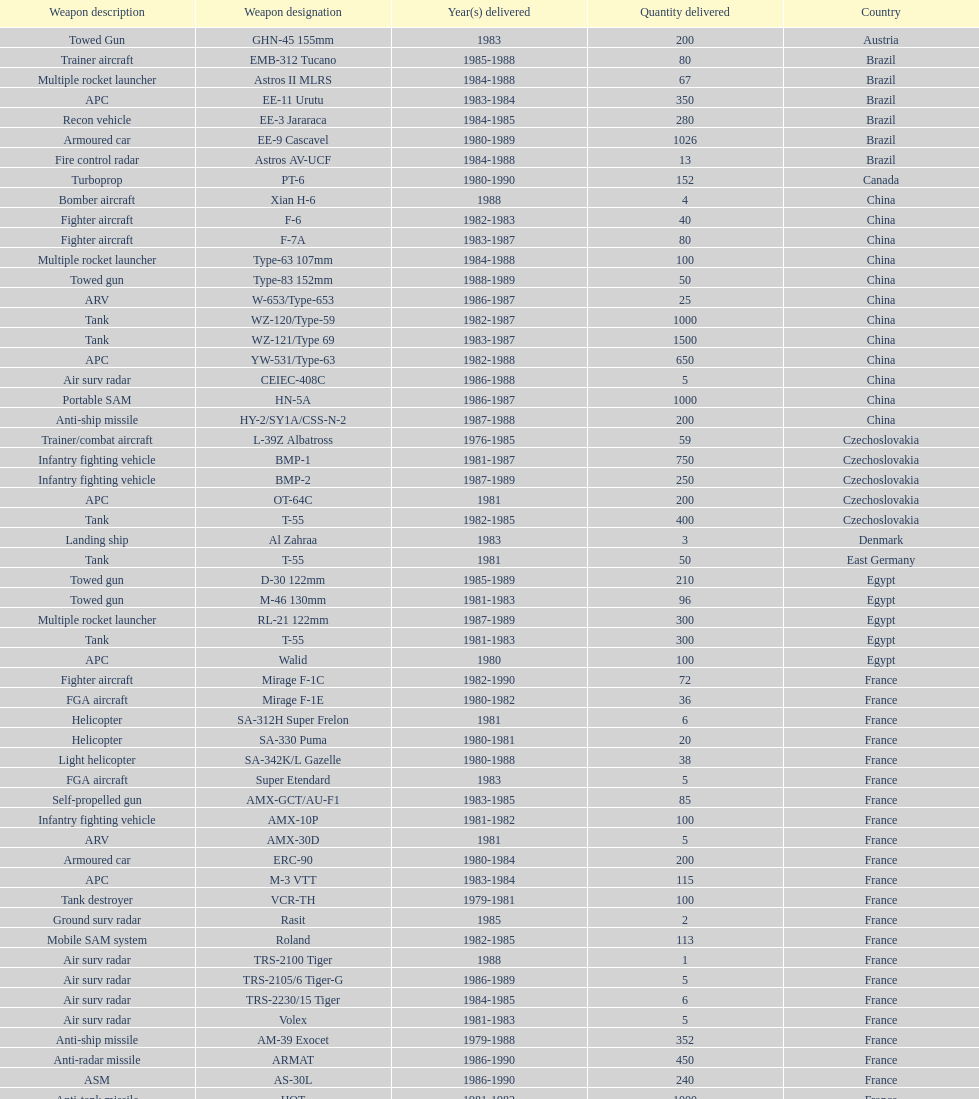Write the full table. {'header': ['Weapon description', 'Weapon designation', 'Year(s) delivered', 'Quantity delivered', 'Country'], 'rows': [['Towed Gun', 'GHN-45 155mm', '1983', '200', 'Austria'], ['Trainer aircraft', 'EMB-312 Tucano', '1985-1988', '80', 'Brazil'], ['Multiple rocket launcher', 'Astros II MLRS', '1984-1988', '67', 'Brazil'], ['APC', 'EE-11 Urutu', '1983-1984', '350', 'Brazil'], ['Recon vehicle', 'EE-3 Jararaca', '1984-1985', '280', 'Brazil'], ['Armoured car', 'EE-9 Cascavel', '1980-1989', '1026', 'Brazil'], ['Fire control radar', 'Astros AV-UCF', '1984-1988', '13', 'Brazil'], ['Turboprop', 'PT-6', '1980-1990', '152', 'Canada'], ['Bomber aircraft', 'Xian H-6', '1988', '4', 'China'], ['Fighter aircraft', 'F-6', '1982-1983', '40', 'China'], ['Fighter aircraft', 'F-7A', '1983-1987', '80', 'China'], ['Multiple rocket launcher', 'Type-63 107mm', '1984-1988', '100', 'China'], ['Towed gun', 'Type-83 152mm', '1988-1989', '50', 'China'], ['ARV', 'W-653/Type-653', '1986-1987', '25', 'China'], ['Tank', 'WZ-120/Type-59', '1982-1987', '1000', 'China'], ['Tank', 'WZ-121/Type 69', '1983-1987', '1500', 'China'], ['APC', 'YW-531/Type-63', '1982-1988', '650', 'China'], ['Air surv radar', 'CEIEC-408C', '1986-1988', '5', 'China'], ['Portable SAM', 'HN-5A', '1986-1987', '1000', 'China'], ['Anti-ship missile', 'HY-2/SY1A/CSS-N-2', '1987-1988', '200', 'China'], ['Trainer/combat aircraft', 'L-39Z Albatross', '1976-1985', '59', 'Czechoslovakia'], ['Infantry fighting vehicle', 'BMP-1', '1981-1987', '750', 'Czechoslovakia'], ['Infantry fighting vehicle', 'BMP-2', '1987-1989', '250', 'Czechoslovakia'], ['APC', 'OT-64C', '1981', '200', 'Czechoslovakia'], ['Tank', 'T-55', '1982-1985', '400', 'Czechoslovakia'], ['Landing ship', 'Al Zahraa', '1983', '3', 'Denmark'], ['Tank', 'T-55', '1981', '50', 'East Germany'], ['Towed gun', 'D-30 122mm', '1985-1989', '210', 'Egypt'], ['Towed gun', 'M-46 130mm', '1981-1983', '96', 'Egypt'], ['Multiple rocket launcher', 'RL-21 122mm', '1987-1989', '300', 'Egypt'], ['Tank', 'T-55', '1981-1983', '300', 'Egypt'], ['APC', 'Walid', '1980', '100', 'Egypt'], ['Fighter aircraft', 'Mirage F-1C', '1982-1990', '72', 'France'], ['FGA aircraft', 'Mirage F-1E', '1980-1982', '36', 'France'], ['Helicopter', 'SA-312H Super Frelon', '1981', '6', 'France'], ['Helicopter', 'SA-330 Puma', '1980-1981', '20', 'France'], ['Light helicopter', 'SA-342K/L Gazelle', '1980-1988', '38', 'France'], ['FGA aircraft', 'Super Etendard', '1983', '5', 'France'], ['Self-propelled gun', 'AMX-GCT/AU-F1', '1983-1985', '85', 'France'], ['Infantry fighting vehicle', 'AMX-10P', '1981-1982', '100', 'France'], ['ARV', 'AMX-30D', '1981', '5', 'France'], ['Armoured car', 'ERC-90', '1980-1984', '200', 'France'], ['APC', 'M-3 VTT', '1983-1984', '115', 'France'], ['Tank destroyer', 'VCR-TH', '1979-1981', '100', 'France'], ['Ground surv radar', 'Rasit', '1985', '2', 'France'], ['Mobile SAM system', 'Roland', '1982-1985', '113', 'France'], ['Air surv radar', 'TRS-2100 Tiger', '1988', '1', 'France'], ['Air surv radar', 'TRS-2105/6 Tiger-G', '1986-1989', '5', 'France'], ['Air surv radar', 'TRS-2230/15 Tiger', '1984-1985', '6', 'France'], ['Air surv radar', 'Volex', '1981-1983', '5', 'France'], ['Anti-ship missile', 'AM-39 Exocet', '1979-1988', '352', 'France'], ['Anti-radar missile', 'ARMAT', '1986-1990', '450', 'France'], ['ASM', 'AS-30L', '1986-1990', '240', 'France'], ['Anti-tank missile', 'HOT', '1981-1982', '1000', 'France'], ['SRAAM', 'R-550 Magic-1', '1981-1985', '534', 'France'], ['SAM', 'Roland-2', '1981-1990', '2260', 'France'], ['BVRAAM', 'Super 530F', '1981-1985', '300', 'France'], ['Helicopter', 'BK-117', '1984-1989', '22', 'West Germany'], ['Light Helicopter', 'Bo-105C', '1979-1982', '20', 'West Germany'], ['Light Helicopter', 'Bo-105L', '1988', '6', 'West Germany'], ['APC', 'PSZH-D-994', '1981', '300', 'Hungary'], ['Light Helicopter', 'A-109 Hirundo', '1982', '2', 'Italy'], ['Helicopter', 'S-61', '1982', '6', 'Italy'], ['Support ship', 'Stromboli class', '1981', '1', 'Italy'], ['Helicopter', 'S-76 Spirit', '1985', '2', 'Jordan'], ['Helicopter', 'Mi-2/Hoplite', '1984-1985', '15', 'Poland'], ['APC', 'MT-LB', '1983-1990', '750', 'Poland'], ['Tank', 'T-55', '1981-1982', '400', 'Poland'], ['Tank', 'T-72M1', '1982-1990', '500', 'Poland'], ['Tank', 'T-55', '1982-1984', '150', 'Romania'], ['Multiple rocket launcher', 'M-87 Orkan 262mm', '1988', '2', 'Yugoslavia'], ['Towed gun', 'G-5 155mm', '1985-1988', '200', 'South Africa'], ['Trainer aircraft', 'PC-7 Turbo trainer', '1980-1983', '52', 'Switzerland'], ['Trainer aircraft', 'PC-9', '1987-1990', '20', 'Switzerland'], ['APC/IFV', 'Roland', '1981', '100', 'Switzerland'], ['ARV', 'Chieftain/ARV', '1982', '29', 'United Kingdom'], ['Arty locating radar', 'Cymbeline', '1986-1988', '10', 'United Kingdom'], ['Light Helicopter', 'MD-500MD Defender', '1983', '30', 'United States'], ['Light Helicopter', 'Hughes-300/TH-55', '1983', '30', 'United States'], ['Light Helicopter', 'MD-530F', '1986', '26', 'United States'], ['Helicopter', 'Bell 214ST', '1988', '31', 'United States'], ['Strategic airlifter', 'Il-76M/Candid-B', '1978-1984', '33', 'Soviet Union'], ['Attack helicopter', 'Mi-24D/Mi-25/Hind-D', '1978-1984', '12', 'Soviet Union'], ['Transport helicopter', 'Mi-8/Mi-17/Hip-H', '1986-1987', '37', 'Soviet Union'], ['Transport helicopter', 'Mi-8TV/Hip-F', '1984', '30', 'Soviet Union'], ['Fighter aircraft', 'Mig-21bis/Fishbed-N', '1983-1984', '61', 'Soviet Union'], ['FGA aircraft', 'Mig-23BN/Flogger-H', '1984-1985', '50', 'Soviet Union'], ['Interceptor aircraft', 'Mig-25P/Foxbat-A', '1980-1985', '55', 'Soviet Union'], ['Recon aircraft', 'Mig-25RB/Foxbat-B', '1982', '8', 'Soviet Union'], ['Fighter aircraft', 'Mig-29/Fulcrum-A', '1986-1989', '41', 'Soviet Union'], ['FGA aircraft', 'Su-22/Fitter-H/J/K', '1986-1987', '61', 'Soviet Union'], ['Ground attack aircraft', 'Su-25/Frogfoot-A', '1986-1987', '84', 'Soviet Union'], ['Towed gun', '2A36 152mm', '1986-1988', '180', 'Soviet Union'], ['Self-Propelled Howitzer', '2S1 122mm', '1980-1989', '150', 'Soviet Union'], ['Self-propelled gun', '2S3 152mm', '1980-1989', '150', 'Soviet Union'], ['Self-propelled mortar', '2S4 240mm', '1983', '10', 'Soviet Union'], ['SSM launcher', '9P117/SS-1 Scud TEL', '1983-1984', '10', 'Soviet Union'], ['Multiple rocket launcher', 'BM-21 Grad 122mm', '1983-1988', '560', 'Soviet Union'], ['Towed gun', 'D-30 122mm', '1982-1988', '576', 'Soviet Union'], ['Mortar', 'M-240 240mm', '1981', '25', 'Soviet Union'], ['Towed Gun', 'M-46 130mm', '1982-1987', '576', 'Soviet Union'], ['AAV(M)', '9K35 Strela-10/SA-13', '1985', '30', 'Soviet Union'], ['IFV', 'BMD-1', '1981', '10', 'Soviet Union'], ['Light tank', 'PT-76', '1984', '200', 'Soviet Union'], ['AAV(M)', 'SA-9/9P31', '1982-1985', '160', 'Soviet Union'], ['Air surv radar', 'Long Track', '1980-1984', '10', 'Soviet Union'], ['Mobile SAM system', 'SA-8b/9K33M Osa AK', '1982-1985', '50', 'Soviet Union'], ['Air surv radar', 'Thin Skin', '1980-1984', '5', 'Soviet Union'], ['Anti-tank missile', '9M111/AT-4 Spigot', '1986-1989', '3000', 'Soviet Union'], ['SAM', '9M37/SA-13 Gopher', '1985-1986', '960', 'Soviet Union'], ['Anti-ship missile', 'KSR-5/AS-6 Kingfish', '1984', '36', 'Soviet Union'], ['Anti-radar missile', 'Kh-28/AS-9 Kyle', '1983-1988', '250', 'Soviet Union'], ['SRAAM', 'R-13S/AA2S Atoll', '1984-1987', '1080', 'Soviet Union'], ['SSM', 'R-17/SS-1c Scud-B', '1982-1988', '840', 'Soviet Union'], ['BVRAAM', 'R-27/AA-10 Alamo', '1986-1989', '246', 'Soviet Union'], ['BVRAAM', 'R-40R/AA-6 Acrid', '1980-1985', '660', 'Soviet Union'], ['SRAAM', 'R-60/AA-8 Aphid', '1986-1989', '582', 'Soviet Union'], ['SAM', 'SA-8b Gecko/9M33M', '1982-1985', '1290', 'Soviet Union'], ['SAM', 'SA-9 Gaskin/9M31', '1982-1985', '1920', 'Soviet Union'], ['Portable SAM', 'Strela-3/SA-14 Gremlin', '1987-1988', '500', 'Soviet Union']]} Which country had the largest number of towed guns delivered? Soviet Union. 